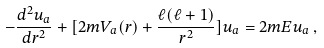<formula> <loc_0><loc_0><loc_500><loc_500>- \frac { d ^ { 2 } u _ { a } } { d r ^ { 2 } } + [ 2 m V _ { a } ( r ) + \frac { \ell ( \ell + 1 ) } { r ^ { 2 } } ] u _ { a } = 2 m E u _ { a } \, ,</formula> 